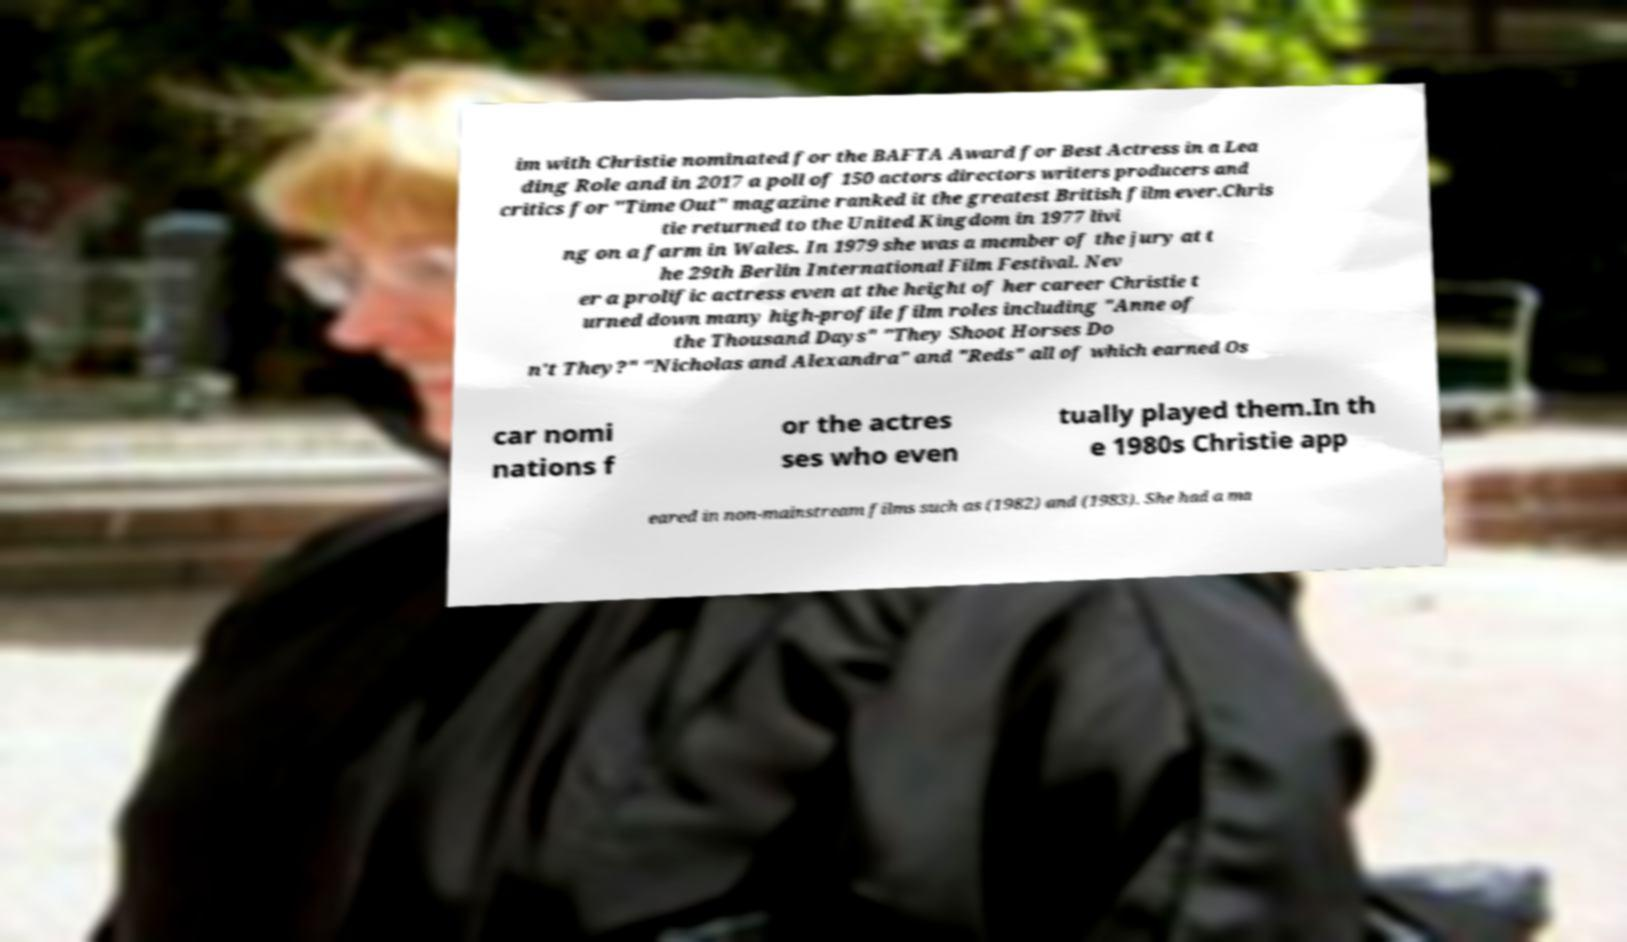Can you accurately transcribe the text from the provided image for me? im with Christie nominated for the BAFTA Award for Best Actress in a Lea ding Role and in 2017 a poll of 150 actors directors writers producers and critics for "Time Out" magazine ranked it the greatest British film ever.Chris tie returned to the United Kingdom in 1977 livi ng on a farm in Wales. In 1979 she was a member of the jury at t he 29th Berlin International Film Festival. Nev er a prolific actress even at the height of her career Christie t urned down many high-profile film roles including "Anne of the Thousand Days" "They Shoot Horses Do n't They?" "Nicholas and Alexandra" and "Reds" all of which earned Os car nomi nations f or the actres ses who even tually played them.In th e 1980s Christie app eared in non-mainstream films such as (1982) and (1983). She had a ma 